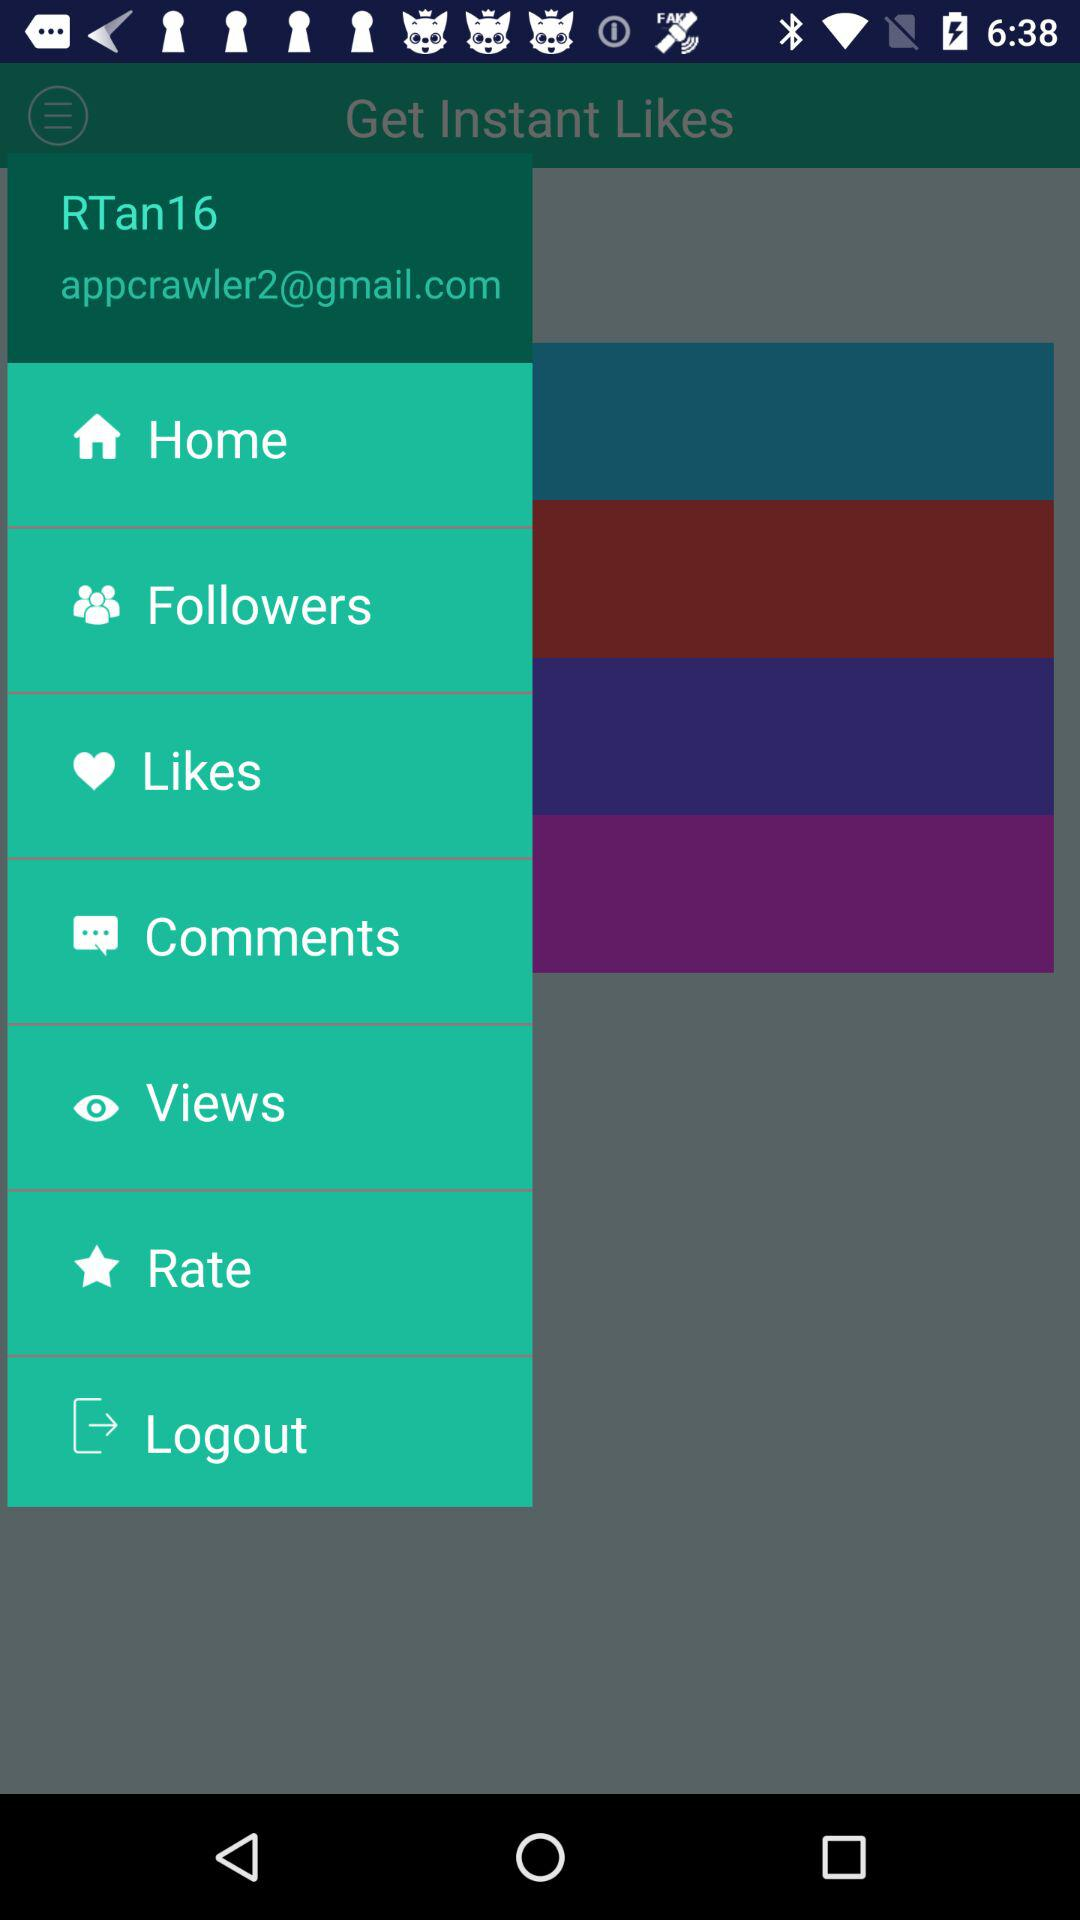What is the profile name? The profile name is RTan16. 